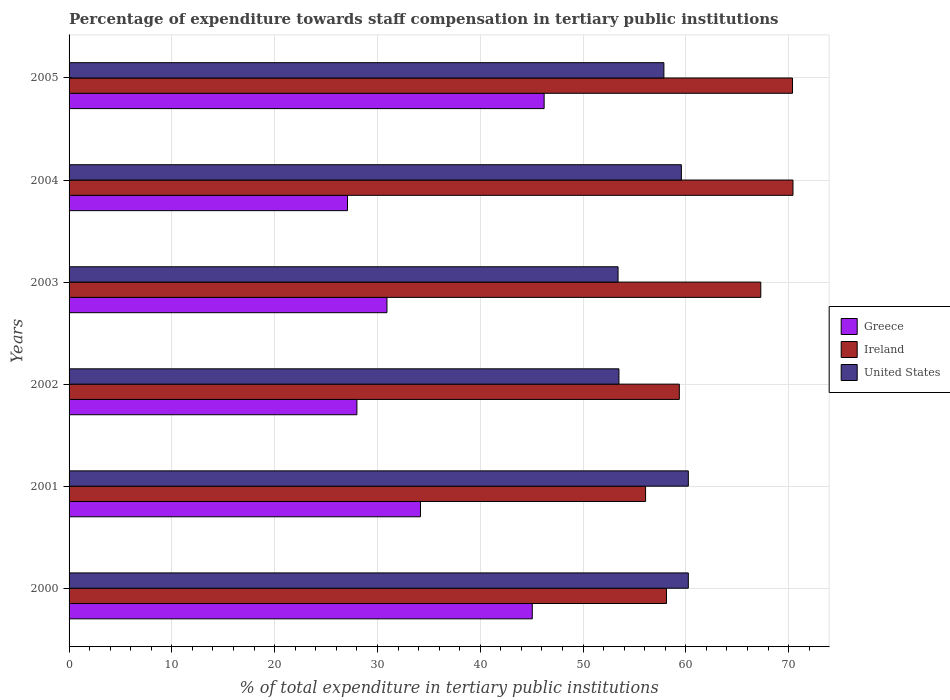How many groups of bars are there?
Ensure brevity in your answer.  6. Are the number of bars per tick equal to the number of legend labels?
Your answer should be very brief. Yes. Are the number of bars on each tick of the Y-axis equal?
Offer a terse response. Yes. What is the label of the 3rd group of bars from the top?
Offer a terse response. 2003. What is the percentage of expenditure towards staff compensation in Greece in 2002?
Give a very brief answer. 28. Across all years, what is the maximum percentage of expenditure towards staff compensation in United States?
Offer a very short reply. 60.24. Across all years, what is the minimum percentage of expenditure towards staff compensation in Greece?
Offer a terse response. 27.09. In which year was the percentage of expenditure towards staff compensation in United States maximum?
Provide a succinct answer. 2000. What is the total percentage of expenditure towards staff compensation in United States in the graph?
Ensure brevity in your answer.  344.81. What is the difference between the percentage of expenditure towards staff compensation in United States in 2001 and that in 2005?
Your response must be concise. 2.38. What is the difference between the percentage of expenditure towards staff compensation in Greece in 2004 and the percentage of expenditure towards staff compensation in United States in 2002?
Offer a very short reply. -26.41. What is the average percentage of expenditure towards staff compensation in Greece per year?
Your answer should be compact. 35.25. In the year 2005, what is the difference between the percentage of expenditure towards staff compensation in United States and percentage of expenditure towards staff compensation in Ireland?
Your answer should be compact. -12.51. In how many years, is the percentage of expenditure towards staff compensation in United States greater than 60 %?
Your answer should be very brief. 2. What is the ratio of the percentage of expenditure towards staff compensation in United States in 2001 to that in 2005?
Your answer should be very brief. 1.04. Is the difference between the percentage of expenditure towards staff compensation in United States in 2000 and 2004 greater than the difference between the percentage of expenditure towards staff compensation in Ireland in 2000 and 2004?
Give a very brief answer. Yes. What is the difference between the highest and the second highest percentage of expenditure towards staff compensation in Greece?
Give a very brief answer. 1.15. What is the difference between the highest and the lowest percentage of expenditure towards staff compensation in United States?
Your response must be concise. 6.84. In how many years, is the percentage of expenditure towards staff compensation in Greece greater than the average percentage of expenditure towards staff compensation in Greece taken over all years?
Keep it short and to the point. 2. What does the 2nd bar from the bottom in 2004 represents?
Keep it short and to the point. Ireland. How many years are there in the graph?
Provide a short and direct response. 6. Does the graph contain any zero values?
Your answer should be very brief. No. Does the graph contain grids?
Your answer should be compact. Yes. Where does the legend appear in the graph?
Give a very brief answer. Center right. How many legend labels are there?
Ensure brevity in your answer.  3. How are the legend labels stacked?
Provide a succinct answer. Vertical. What is the title of the graph?
Make the answer very short. Percentage of expenditure towards staff compensation in tertiary public institutions. What is the label or title of the X-axis?
Make the answer very short. % of total expenditure in tertiary public institutions. What is the label or title of the Y-axis?
Give a very brief answer. Years. What is the % of total expenditure in tertiary public institutions of Greece in 2000?
Your response must be concise. 45.06. What is the % of total expenditure in tertiary public institutions of Ireland in 2000?
Your answer should be very brief. 58.12. What is the % of total expenditure in tertiary public institutions in United States in 2000?
Offer a very short reply. 60.24. What is the % of total expenditure in tertiary public institutions of Greece in 2001?
Your answer should be very brief. 34.19. What is the % of total expenditure in tertiary public institutions in Ireland in 2001?
Keep it short and to the point. 56.08. What is the % of total expenditure in tertiary public institutions of United States in 2001?
Keep it short and to the point. 60.24. What is the % of total expenditure in tertiary public institutions in Greece in 2002?
Give a very brief answer. 28. What is the % of total expenditure in tertiary public institutions of Ireland in 2002?
Give a very brief answer. 59.37. What is the % of total expenditure in tertiary public institutions in United States in 2002?
Keep it short and to the point. 53.49. What is the % of total expenditure in tertiary public institutions of Greece in 2003?
Provide a short and direct response. 30.92. What is the % of total expenditure in tertiary public institutions of Ireland in 2003?
Provide a succinct answer. 67.29. What is the % of total expenditure in tertiary public institutions of United States in 2003?
Ensure brevity in your answer.  53.41. What is the % of total expenditure in tertiary public institutions in Greece in 2004?
Your response must be concise. 27.09. What is the % of total expenditure in tertiary public institutions in Ireland in 2004?
Your answer should be compact. 70.42. What is the % of total expenditure in tertiary public institutions of United States in 2004?
Keep it short and to the point. 59.56. What is the % of total expenditure in tertiary public institutions in Greece in 2005?
Give a very brief answer. 46.22. What is the % of total expenditure in tertiary public institutions of Ireland in 2005?
Offer a very short reply. 70.38. What is the % of total expenditure in tertiary public institutions in United States in 2005?
Your answer should be compact. 57.86. Across all years, what is the maximum % of total expenditure in tertiary public institutions in Greece?
Provide a short and direct response. 46.22. Across all years, what is the maximum % of total expenditure in tertiary public institutions in Ireland?
Offer a terse response. 70.42. Across all years, what is the maximum % of total expenditure in tertiary public institutions in United States?
Offer a very short reply. 60.24. Across all years, what is the minimum % of total expenditure in tertiary public institutions in Greece?
Give a very brief answer. 27.09. Across all years, what is the minimum % of total expenditure in tertiary public institutions in Ireland?
Your answer should be very brief. 56.08. Across all years, what is the minimum % of total expenditure in tertiary public institutions of United States?
Ensure brevity in your answer.  53.41. What is the total % of total expenditure in tertiary public institutions of Greece in the graph?
Offer a very short reply. 211.47. What is the total % of total expenditure in tertiary public institutions in Ireland in the graph?
Your answer should be compact. 381.66. What is the total % of total expenditure in tertiary public institutions in United States in the graph?
Ensure brevity in your answer.  344.81. What is the difference between the % of total expenditure in tertiary public institutions of Greece in 2000 and that in 2001?
Your response must be concise. 10.88. What is the difference between the % of total expenditure in tertiary public institutions in Ireland in 2000 and that in 2001?
Make the answer very short. 2.04. What is the difference between the % of total expenditure in tertiary public institutions of Greece in 2000 and that in 2002?
Make the answer very short. 17.06. What is the difference between the % of total expenditure in tertiary public institutions in Ireland in 2000 and that in 2002?
Your answer should be very brief. -1.25. What is the difference between the % of total expenditure in tertiary public institutions in United States in 2000 and that in 2002?
Your answer should be very brief. 6.75. What is the difference between the % of total expenditure in tertiary public institutions in Greece in 2000 and that in 2003?
Ensure brevity in your answer.  14.14. What is the difference between the % of total expenditure in tertiary public institutions in Ireland in 2000 and that in 2003?
Give a very brief answer. -9.17. What is the difference between the % of total expenditure in tertiary public institutions in United States in 2000 and that in 2003?
Ensure brevity in your answer.  6.84. What is the difference between the % of total expenditure in tertiary public institutions of Greece in 2000 and that in 2004?
Make the answer very short. 17.98. What is the difference between the % of total expenditure in tertiary public institutions of Ireland in 2000 and that in 2004?
Your response must be concise. -12.3. What is the difference between the % of total expenditure in tertiary public institutions of United States in 2000 and that in 2004?
Offer a very short reply. 0.68. What is the difference between the % of total expenditure in tertiary public institutions in Greece in 2000 and that in 2005?
Give a very brief answer. -1.15. What is the difference between the % of total expenditure in tertiary public institutions in Ireland in 2000 and that in 2005?
Offer a terse response. -12.26. What is the difference between the % of total expenditure in tertiary public institutions of United States in 2000 and that in 2005?
Keep it short and to the point. 2.38. What is the difference between the % of total expenditure in tertiary public institutions in Greece in 2001 and that in 2002?
Your answer should be compact. 6.18. What is the difference between the % of total expenditure in tertiary public institutions of Ireland in 2001 and that in 2002?
Offer a very short reply. -3.28. What is the difference between the % of total expenditure in tertiary public institutions in United States in 2001 and that in 2002?
Offer a very short reply. 6.75. What is the difference between the % of total expenditure in tertiary public institutions in Greece in 2001 and that in 2003?
Offer a terse response. 3.26. What is the difference between the % of total expenditure in tertiary public institutions of Ireland in 2001 and that in 2003?
Your answer should be compact. -11.21. What is the difference between the % of total expenditure in tertiary public institutions in United States in 2001 and that in 2003?
Give a very brief answer. 6.84. What is the difference between the % of total expenditure in tertiary public institutions of Greece in 2001 and that in 2004?
Keep it short and to the point. 7.1. What is the difference between the % of total expenditure in tertiary public institutions in Ireland in 2001 and that in 2004?
Offer a very short reply. -14.34. What is the difference between the % of total expenditure in tertiary public institutions in United States in 2001 and that in 2004?
Give a very brief answer. 0.68. What is the difference between the % of total expenditure in tertiary public institutions of Greece in 2001 and that in 2005?
Provide a short and direct response. -12.03. What is the difference between the % of total expenditure in tertiary public institutions in Ireland in 2001 and that in 2005?
Give a very brief answer. -14.29. What is the difference between the % of total expenditure in tertiary public institutions in United States in 2001 and that in 2005?
Give a very brief answer. 2.38. What is the difference between the % of total expenditure in tertiary public institutions in Greece in 2002 and that in 2003?
Keep it short and to the point. -2.92. What is the difference between the % of total expenditure in tertiary public institutions of Ireland in 2002 and that in 2003?
Provide a succinct answer. -7.92. What is the difference between the % of total expenditure in tertiary public institutions of United States in 2002 and that in 2003?
Your answer should be compact. 0.09. What is the difference between the % of total expenditure in tertiary public institutions in Greece in 2002 and that in 2004?
Provide a succinct answer. 0.92. What is the difference between the % of total expenditure in tertiary public institutions of Ireland in 2002 and that in 2004?
Give a very brief answer. -11.06. What is the difference between the % of total expenditure in tertiary public institutions in United States in 2002 and that in 2004?
Keep it short and to the point. -6.07. What is the difference between the % of total expenditure in tertiary public institutions of Greece in 2002 and that in 2005?
Provide a short and direct response. -18.21. What is the difference between the % of total expenditure in tertiary public institutions in Ireland in 2002 and that in 2005?
Provide a succinct answer. -11.01. What is the difference between the % of total expenditure in tertiary public institutions in United States in 2002 and that in 2005?
Offer a very short reply. -4.37. What is the difference between the % of total expenditure in tertiary public institutions in Greece in 2003 and that in 2004?
Offer a very short reply. 3.84. What is the difference between the % of total expenditure in tertiary public institutions of Ireland in 2003 and that in 2004?
Offer a very short reply. -3.13. What is the difference between the % of total expenditure in tertiary public institutions in United States in 2003 and that in 2004?
Your answer should be compact. -6.16. What is the difference between the % of total expenditure in tertiary public institutions in Greece in 2003 and that in 2005?
Offer a very short reply. -15.29. What is the difference between the % of total expenditure in tertiary public institutions of Ireland in 2003 and that in 2005?
Make the answer very short. -3.09. What is the difference between the % of total expenditure in tertiary public institutions of United States in 2003 and that in 2005?
Make the answer very short. -4.46. What is the difference between the % of total expenditure in tertiary public institutions in Greece in 2004 and that in 2005?
Provide a succinct answer. -19.13. What is the difference between the % of total expenditure in tertiary public institutions of Ireland in 2004 and that in 2005?
Your response must be concise. 0.05. What is the difference between the % of total expenditure in tertiary public institutions of United States in 2004 and that in 2005?
Provide a short and direct response. 1.7. What is the difference between the % of total expenditure in tertiary public institutions in Greece in 2000 and the % of total expenditure in tertiary public institutions in Ireland in 2001?
Offer a very short reply. -11.02. What is the difference between the % of total expenditure in tertiary public institutions of Greece in 2000 and the % of total expenditure in tertiary public institutions of United States in 2001?
Offer a very short reply. -15.18. What is the difference between the % of total expenditure in tertiary public institutions in Ireland in 2000 and the % of total expenditure in tertiary public institutions in United States in 2001?
Provide a short and direct response. -2.12. What is the difference between the % of total expenditure in tertiary public institutions of Greece in 2000 and the % of total expenditure in tertiary public institutions of Ireland in 2002?
Give a very brief answer. -14.3. What is the difference between the % of total expenditure in tertiary public institutions of Greece in 2000 and the % of total expenditure in tertiary public institutions of United States in 2002?
Offer a terse response. -8.43. What is the difference between the % of total expenditure in tertiary public institutions of Ireland in 2000 and the % of total expenditure in tertiary public institutions of United States in 2002?
Offer a very short reply. 4.63. What is the difference between the % of total expenditure in tertiary public institutions of Greece in 2000 and the % of total expenditure in tertiary public institutions of Ireland in 2003?
Your response must be concise. -22.23. What is the difference between the % of total expenditure in tertiary public institutions of Greece in 2000 and the % of total expenditure in tertiary public institutions of United States in 2003?
Provide a short and direct response. -8.34. What is the difference between the % of total expenditure in tertiary public institutions in Ireland in 2000 and the % of total expenditure in tertiary public institutions in United States in 2003?
Offer a very short reply. 4.71. What is the difference between the % of total expenditure in tertiary public institutions of Greece in 2000 and the % of total expenditure in tertiary public institutions of Ireland in 2004?
Your response must be concise. -25.36. What is the difference between the % of total expenditure in tertiary public institutions of Greece in 2000 and the % of total expenditure in tertiary public institutions of United States in 2004?
Make the answer very short. -14.5. What is the difference between the % of total expenditure in tertiary public institutions in Ireland in 2000 and the % of total expenditure in tertiary public institutions in United States in 2004?
Your answer should be compact. -1.44. What is the difference between the % of total expenditure in tertiary public institutions in Greece in 2000 and the % of total expenditure in tertiary public institutions in Ireland in 2005?
Make the answer very short. -25.32. What is the difference between the % of total expenditure in tertiary public institutions of Greece in 2000 and the % of total expenditure in tertiary public institutions of United States in 2005?
Your answer should be very brief. -12.8. What is the difference between the % of total expenditure in tertiary public institutions of Ireland in 2000 and the % of total expenditure in tertiary public institutions of United States in 2005?
Provide a short and direct response. 0.26. What is the difference between the % of total expenditure in tertiary public institutions of Greece in 2001 and the % of total expenditure in tertiary public institutions of Ireland in 2002?
Ensure brevity in your answer.  -25.18. What is the difference between the % of total expenditure in tertiary public institutions in Greece in 2001 and the % of total expenditure in tertiary public institutions in United States in 2002?
Keep it short and to the point. -19.31. What is the difference between the % of total expenditure in tertiary public institutions of Ireland in 2001 and the % of total expenditure in tertiary public institutions of United States in 2002?
Ensure brevity in your answer.  2.59. What is the difference between the % of total expenditure in tertiary public institutions of Greece in 2001 and the % of total expenditure in tertiary public institutions of Ireland in 2003?
Your answer should be compact. -33.11. What is the difference between the % of total expenditure in tertiary public institutions in Greece in 2001 and the % of total expenditure in tertiary public institutions in United States in 2003?
Your response must be concise. -19.22. What is the difference between the % of total expenditure in tertiary public institutions of Ireland in 2001 and the % of total expenditure in tertiary public institutions of United States in 2003?
Make the answer very short. 2.68. What is the difference between the % of total expenditure in tertiary public institutions in Greece in 2001 and the % of total expenditure in tertiary public institutions in Ireland in 2004?
Offer a very short reply. -36.24. What is the difference between the % of total expenditure in tertiary public institutions of Greece in 2001 and the % of total expenditure in tertiary public institutions of United States in 2004?
Provide a succinct answer. -25.38. What is the difference between the % of total expenditure in tertiary public institutions in Ireland in 2001 and the % of total expenditure in tertiary public institutions in United States in 2004?
Ensure brevity in your answer.  -3.48. What is the difference between the % of total expenditure in tertiary public institutions of Greece in 2001 and the % of total expenditure in tertiary public institutions of Ireland in 2005?
Keep it short and to the point. -36.19. What is the difference between the % of total expenditure in tertiary public institutions of Greece in 2001 and the % of total expenditure in tertiary public institutions of United States in 2005?
Keep it short and to the point. -23.68. What is the difference between the % of total expenditure in tertiary public institutions of Ireland in 2001 and the % of total expenditure in tertiary public institutions of United States in 2005?
Keep it short and to the point. -1.78. What is the difference between the % of total expenditure in tertiary public institutions in Greece in 2002 and the % of total expenditure in tertiary public institutions in Ireland in 2003?
Offer a very short reply. -39.29. What is the difference between the % of total expenditure in tertiary public institutions in Greece in 2002 and the % of total expenditure in tertiary public institutions in United States in 2003?
Ensure brevity in your answer.  -25.41. What is the difference between the % of total expenditure in tertiary public institutions in Ireland in 2002 and the % of total expenditure in tertiary public institutions in United States in 2003?
Keep it short and to the point. 5.96. What is the difference between the % of total expenditure in tertiary public institutions of Greece in 2002 and the % of total expenditure in tertiary public institutions of Ireland in 2004?
Give a very brief answer. -42.42. What is the difference between the % of total expenditure in tertiary public institutions in Greece in 2002 and the % of total expenditure in tertiary public institutions in United States in 2004?
Provide a short and direct response. -31.56. What is the difference between the % of total expenditure in tertiary public institutions of Ireland in 2002 and the % of total expenditure in tertiary public institutions of United States in 2004?
Offer a very short reply. -0.2. What is the difference between the % of total expenditure in tertiary public institutions in Greece in 2002 and the % of total expenditure in tertiary public institutions in Ireland in 2005?
Your answer should be compact. -42.38. What is the difference between the % of total expenditure in tertiary public institutions in Greece in 2002 and the % of total expenditure in tertiary public institutions in United States in 2005?
Give a very brief answer. -29.86. What is the difference between the % of total expenditure in tertiary public institutions of Ireland in 2002 and the % of total expenditure in tertiary public institutions of United States in 2005?
Provide a short and direct response. 1.5. What is the difference between the % of total expenditure in tertiary public institutions of Greece in 2003 and the % of total expenditure in tertiary public institutions of Ireland in 2004?
Ensure brevity in your answer.  -39.5. What is the difference between the % of total expenditure in tertiary public institutions in Greece in 2003 and the % of total expenditure in tertiary public institutions in United States in 2004?
Give a very brief answer. -28.64. What is the difference between the % of total expenditure in tertiary public institutions in Ireland in 2003 and the % of total expenditure in tertiary public institutions in United States in 2004?
Your answer should be very brief. 7.73. What is the difference between the % of total expenditure in tertiary public institutions in Greece in 2003 and the % of total expenditure in tertiary public institutions in Ireland in 2005?
Provide a succinct answer. -39.45. What is the difference between the % of total expenditure in tertiary public institutions in Greece in 2003 and the % of total expenditure in tertiary public institutions in United States in 2005?
Offer a very short reply. -26.94. What is the difference between the % of total expenditure in tertiary public institutions of Ireland in 2003 and the % of total expenditure in tertiary public institutions of United States in 2005?
Your answer should be very brief. 9.43. What is the difference between the % of total expenditure in tertiary public institutions in Greece in 2004 and the % of total expenditure in tertiary public institutions in Ireland in 2005?
Provide a succinct answer. -43.29. What is the difference between the % of total expenditure in tertiary public institutions in Greece in 2004 and the % of total expenditure in tertiary public institutions in United States in 2005?
Provide a succinct answer. -30.78. What is the difference between the % of total expenditure in tertiary public institutions of Ireland in 2004 and the % of total expenditure in tertiary public institutions of United States in 2005?
Ensure brevity in your answer.  12.56. What is the average % of total expenditure in tertiary public institutions in Greece per year?
Provide a succinct answer. 35.25. What is the average % of total expenditure in tertiary public institutions of Ireland per year?
Ensure brevity in your answer.  63.61. What is the average % of total expenditure in tertiary public institutions of United States per year?
Your answer should be compact. 57.47. In the year 2000, what is the difference between the % of total expenditure in tertiary public institutions of Greece and % of total expenditure in tertiary public institutions of Ireland?
Provide a succinct answer. -13.06. In the year 2000, what is the difference between the % of total expenditure in tertiary public institutions of Greece and % of total expenditure in tertiary public institutions of United States?
Provide a short and direct response. -15.18. In the year 2000, what is the difference between the % of total expenditure in tertiary public institutions of Ireland and % of total expenditure in tertiary public institutions of United States?
Provide a short and direct response. -2.12. In the year 2001, what is the difference between the % of total expenditure in tertiary public institutions in Greece and % of total expenditure in tertiary public institutions in Ireland?
Ensure brevity in your answer.  -21.9. In the year 2001, what is the difference between the % of total expenditure in tertiary public institutions in Greece and % of total expenditure in tertiary public institutions in United States?
Ensure brevity in your answer.  -26.06. In the year 2001, what is the difference between the % of total expenditure in tertiary public institutions of Ireland and % of total expenditure in tertiary public institutions of United States?
Offer a terse response. -4.16. In the year 2002, what is the difference between the % of total expenditure in tertiary public institutions in Greece and % of total expenditure in tertiary public institutions in Ireland?
Your answer should be very brief. -31.37. In the year 2002, what is the difference between the % of total expenditure in tertiary public institutions of Greece and % of total expenditure in tertiary public institutions of United States?
Offer a terse response. -25.49. In the year 2002, what is the difference between the % of total expenditure in tertiary public institutions in Ireland and % of total expenditure in tertiary public institutions in United States?
Give a very brief answer. 5.87. In the year 2003, what is the difference between the % of total expenditure in tertiary public institutions of Greece and % of total expenditure in tertiary public institutions of Ireland?
Your response must be concise. -36.37. In the year 2003, what is the difference between the % of total expenditure in tertiary public institutions of Greece and % of total expenditure in tertiary public institutions of United States?
Your response must be concise. -22.48. In the year 2003, what is the difference between the % of total expenditure in tertiary public institutions of Ireland and % of total expenditure in tertiary public institutions of United States?
Give a very brief answer. 13.88. In the year 2004, what is the difference between the % of total expenditure in tertiary public institutions of Greece and % of total expenditure in tertiary public institutions of Ireland?
Your answer should be compact. -43.34. In the year 2004, what is the difference between the % of total expenditure in tertiary public institutions of Greece and % of total expenditure in tertiary public institutions of United States?
Your response must be concise. -32.48. In the year 2004, what is the difference between the % of total expenditure in tertiary public institutions of Ireland and % of total expenditure in tertiary public institutions of United States?
Your answer should be compact. 10.86. In the year 2005, what is the difference between the % of total expenditure in tertiary public institutions in Greece and % of total expenditure in tertiary public institutions in Ireland?
Your response must be concise. -24.16. In the year 2005, what is the difference between the % of total expenditure in tertiary public institutions of Greece and % of total expenditure in tertiary public institutions of United States?
Provide a short and direct response. -11.65. In the year 2005, what is the difference between the % of total expenditure in tertiary public institutions in Ireland and % of total expenditure in tertiary public institutions in United States?
Provide a short and direct response. 12.51. What is the ratio of the % of total expenditure in tertiary public institutions of Greece in 2000 to that in 2001?
Make the answer very short. 1.32. What is the ratio of the % of total expenditure in tertiary public institutions in Ireland in 2000 to that in 2001?
Keep it short and to the point. 1.04. What is the ratio of the % of total expenditure in tertiary public institutions in United States in 2000 to that in 2001?
Keep it short and to the point. 1. What is the ratio of the % of total expenditure in tertiary public institutions in Greece in 2000 to that in 2002?
Your response must be concise. 1.61. What is the ratio of the % of total expenditure in tertiary public institutions of Ireland in 2000 to that in 2002?
Provide a succinct answer. 0.98. What is the ratio of the % of total expenditure in tertiary public institutions in United States in 2000 to that in 2002?
Make the answer very short. 1.13. What is the ratio of the % of total expenditure in tertiary public institutions in Greece in 2000 to that in 2003?
Make the answer very short. 1.46. What is the ratio of the % of total expenditure in tertiary public institutions of Ireland in 2000 to that in 2003?
Keep it short and to the point. 0.86. What is the ratio of the % of total expenditure in tertiary public institutions in United States in 2000 to that in 2003?
Provide a short and direct response. 1.13. What is the ratio of the % of total expenditure in tertiary public institutions in Greece in 2000 to that in 2004?
Ensure brevity in your answer.  1.66. What is the ratio of the % of total expenditure in tertiary public institutions in Ireland in 2000 to that in 2004?
Your answer should be compact. 0.83. What is the ratio of the % of total expenditure in tertiary public institutions in United States in 2000 to that in 2004?
Offer a very short reply. 1.01. What is the ratio of the % of total expenditure in tertiary public institutions of Ireland in 2000 to that in 2005?
Give a very brief answer. 0.83. What is the ratio of the % of total expenditure in tertiary public institutions in United States in 2000 to that in 2005?
Your answer should be very brief. 1.04. What is the ratio of the % of total expenditure in tertiary public institutions in Greece in 2001 to that in 2002?
Offer a very short reply. 1.22. What is the ratio of the % of total expenditure in tertiary public institutions in Ireland in 2001 to that in 2002?
Make the answer very short. 0.94. What is the ratio of the % of total expenditure in tertiary public institutions in United States in 2001 to that in 2002?
Provide a short and direct response. 1.13. What is the ratio of the % of total expenditure in tertiary public institutions in Greece in 2001 to that in 2003?
Provide a short and direct response. 1.11. What is the ratio of the % of total expenditure in tertiary public institutions in Ireland in 2001 to that in 2003?
Your answer should be very brief. 0.83. What is the ratio of the % of total expenditure in tertiary public institutions of United States in 2001 to that in 2003?
Provide a short and direct response. 1.13. What is the ratio of the % of total expenditure in tertiary public institutions in Greece in 2001 to that in 2004?
Offer a terse response. 1.26. What is the ratio of the % of total expenditure in tertiary public institutions in Ireland in 2001 to that in 2004?
Your response must be concise. 0.8. What is the ratio of the % of total expenditure in tertiary public institutions in United States in 2001 to that in 2004?
Make the answer very short. 1.01. What is the ratio of the % of total expenditure in tertiary public institutions of Greece in 2001 to that in 2005?
Offer a very short reply. 0.74. What is the ratio of the % of total expenditure in tertiary public institutions of Ireland in 2001 to that in 2005?
Ensure brevity in your answer.  0.8. What is the ratio of the % of total expenditure in tertiary public institutions of United States in 2001 to that in 2005?
Your answer should be very brief. 1.04. What is the ratio of the % of total expenditure in tertiary public institutions of Greece in 2002 to that in 2003?
Provide a succinct answer. 0.91. What is the ratio of the % of total expenditure in tertiary public institutions in Ireland in 2002 to that in 2003?
Make the answer very short. 0.88. What is the ratio of the % of total expenditure in tertiary public institutions of Greece in 2002 to that in 2004?
Make the answer very short. 1.03. What is the ratio of the % of total expenditure in tertiary public institutions of Ireland in 2002 to that in 2004?
Offer a terse response. 0.84. What is the ratio of the % of total expenditure in tertiary public institutions of United States in 2002 to that in 2004?
Provide a short and direct response. 0.9. What is the ratio of the % of total expenditure in tertiary public institutions in Greece in 2002 to that in 2005?
Make the answer very short. 0.61. What is the ratio of the % of total expenditure in tertiary public institutions in Ireland in 2002 to that in 2005?
Make the answer very short. 0.84. What is the ratio of the % of total expenditure in tertiary public institutions of United States in 2002 to that in 2005?
Your answer should be compact. 0.92. What is the ratio of the % of total expenditure in tertiary public institutions in Greece in 2003 to that in 2004?
Your answer should be compact. 1.14. What is the ratio of the % of total expenditure in tertiary public institutions of Ireland in 2003 to that in 2004?
Make the answer very short. 0.96. What is the ratio of the % of total expenditure in tertiary public institutions of United States in 2003 to that in 2004?
Your response must be concise. 0.9. What is the ratio of the % of total expenditure in tertiary public institutions in Greece in 2003 to that in 2005?
Offer a terse response. 0.67. What is the ratio of the % of total expenditure in tertiary public institutions in Ireland in 2003 to that in 2005?
Make the answer very short. 0.96. What is the ratio of the % of total expenditure in tertiary public institutions in United States in 2003 to that in 2005?
Provide a succinct answer. 0.92. What is the ratio of the % of total expenditure in tertiary public institutions of Greece in 2004 to that in 2005?
Your answer should be very brief. 0.59. What is the ratio of the % of total expenditure in tertiary public institutions in Ireland in 2004 to that in 2005?
Give a very brief answer. 1. What is the ratio of the % of total expenditure in tertiary public institutions of United States in 2004 to that in 2005?
Give a very brief answer. 1.03. What is the difference between the highest and the second highest % of total expenditure in tertiary public institutions of Greece?
Offer a very short reply. 1.15. What is the difference between the highest and the second highest % of total expenditure in tertiary public institutions in Ireland?
Offer a very short reply. 0.05. What is the difference between the highest and the lowest % of total expenditure in tertiary public institutions in Greece?
Keep it short and to the point. 19.13. What is the difference between the highest and the lowest % of total expenditure in tertiary public institutions of Ireland?
Offer a very short reply. 14.34. What is the difference between the highest and the lowest % of total expenditure in tertiary public institutions of United States?
Ensure brevity in your answer.  6.84. 